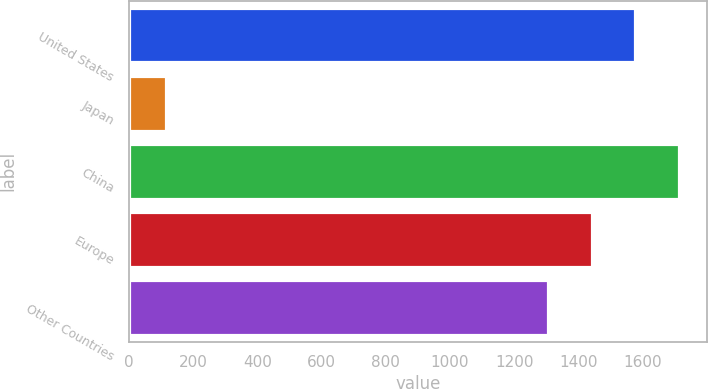<chart> <loc_0><loc_0><loc_500><loc_500><bar_chart><fcel>United States<fcel>Japan<fcel>China<fcel>Europe<fcel>Other Countries<nl><fcel>1577.4<fcel>115<fcel>1713.6<fcel>1441.2<fcel>1305<nl></chart> 